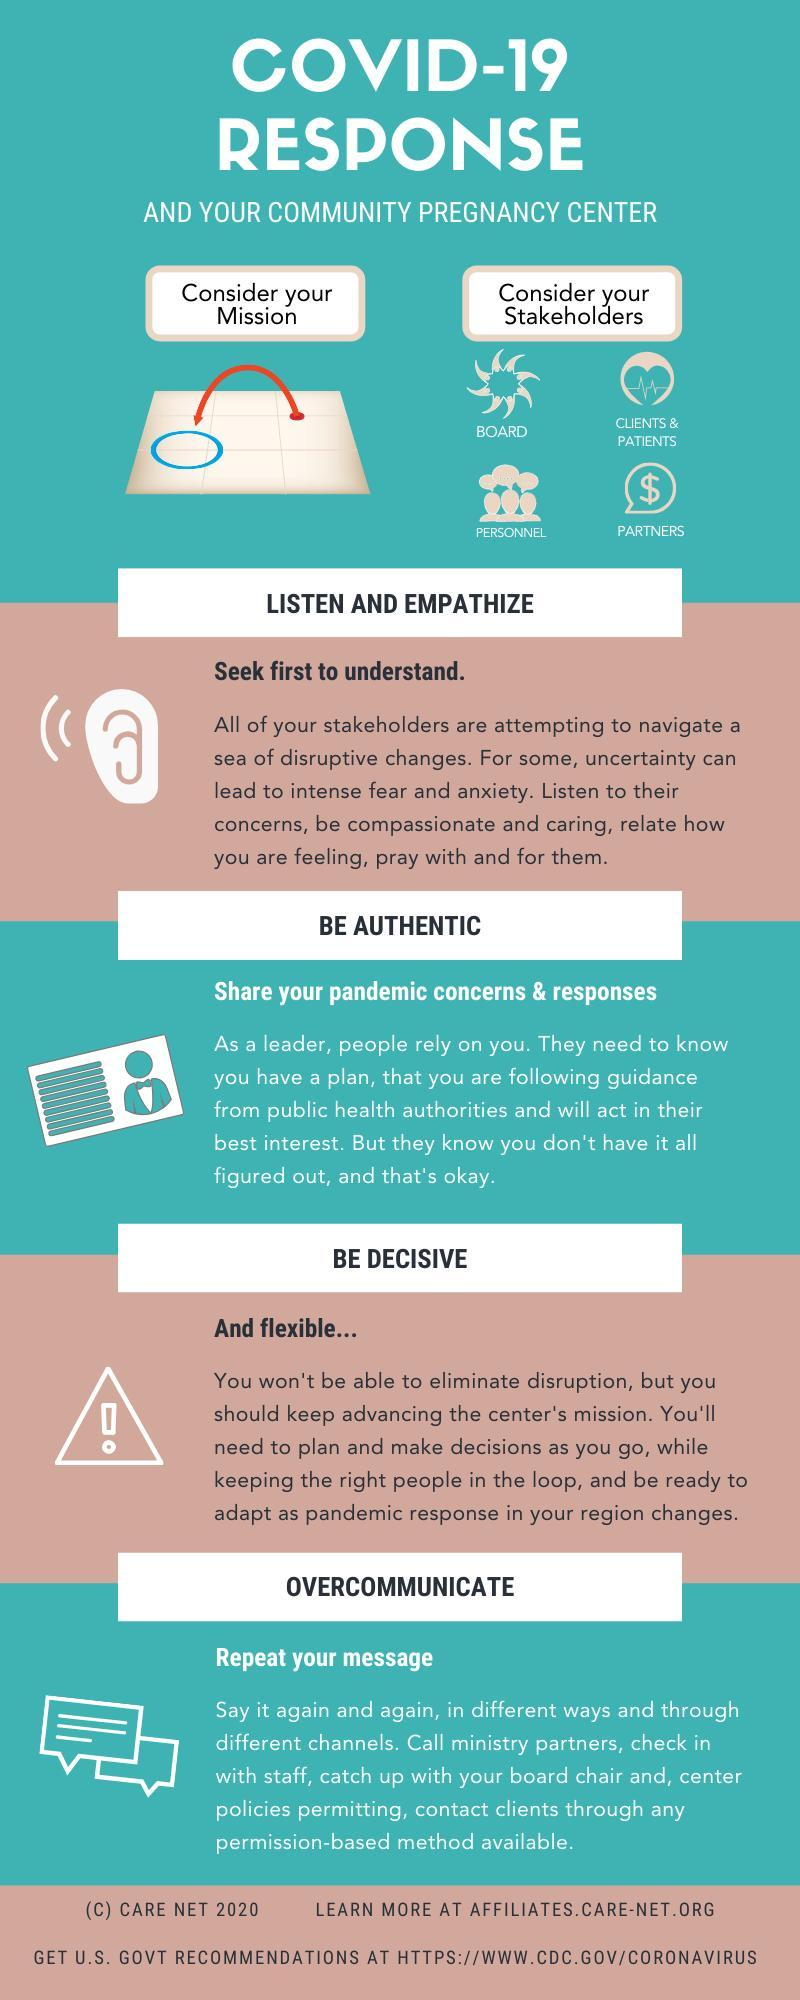How many stakeholders are referenced in this infographic?
Answer the question with a short phrase. 4 